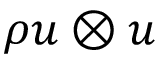Convert formula to latex. <formula><loc_0><loc_0><loc_500><loc_500>\rho u \otimes u</formula> 